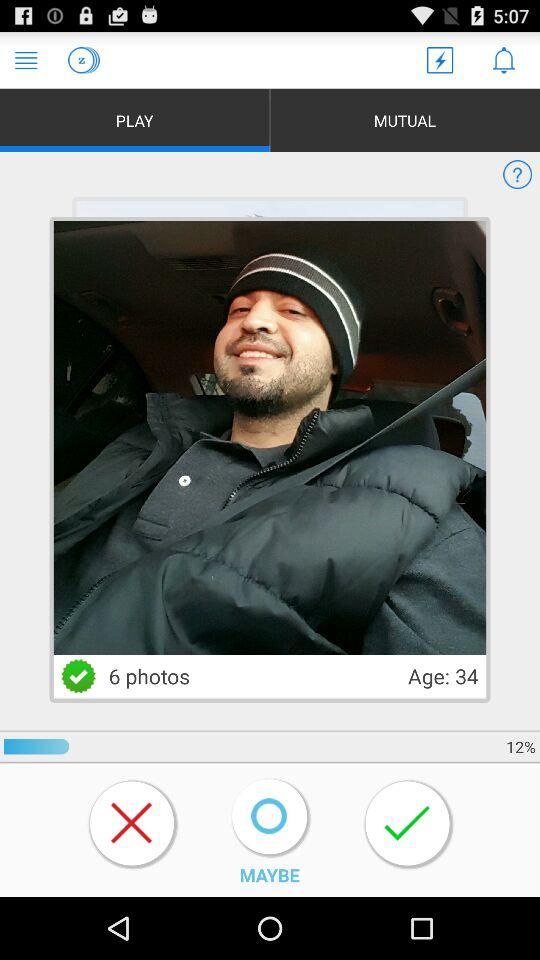What is the total number of photos? The total number of photos is 6. 